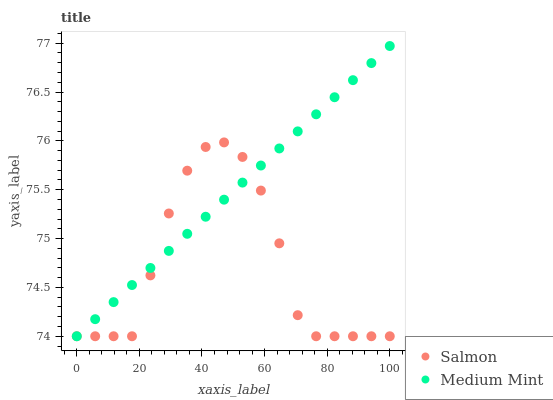Does Salmon have the minimum area under the curve?
Answer yes or no. Yes. Does Medium Mint have the maximum area under the curve?
Answer yes or no. Yes. Does Salmon have the maximum area under the curve?
Answer yes or no. No. Is Medium Mint the smoothest?
Answer yes or no. Yes. Is Salmon the roughest?
Answer yes or no. Yes. Is Salmon the smoothest?
Answer yes or no. No. Does Medium Mint have the lowest value?
Answer yes or no. Yes. Does Medium Mint have the highest value?
Answer yes or no. Yes. Does Salmon have the highest value?
Answer yes or no. No. Does Medium Mint intersect Salmon?
Answer yes or no. Yes. Is Medium Mint less than Salmon?
Answer yes or no. No. Is Medium Mint greater than Salmon?
Answer yes or no. No. 